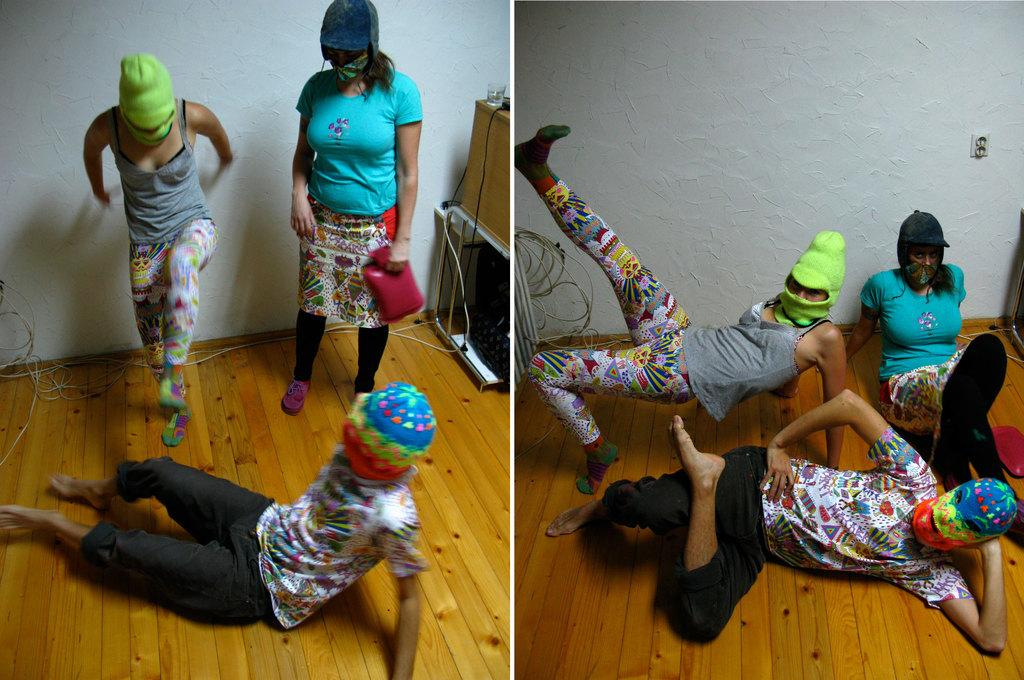How many images are combined to create the collage in the image? The image is a collage of 2 images. How many people are present in the image? There are 3 people in the image. What are the people wearing on their faces? The people are wearing masks. What type of surface are the people standing on? The people are on a wooden surface. What is located behind the wooden surface? There is a wall at the back of the wooden surface. What type of cup is being used by the expert in the image? There is no expert or cup present in the image. What are the people learning in the image? There is no indication of learning in the image; the people are simply standing on a wooden surface while wearing masks. 